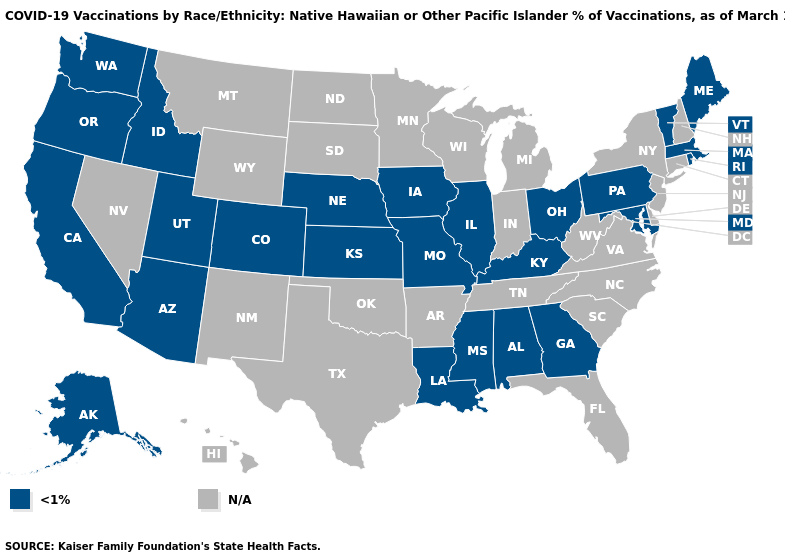Name the states that have a value in the range N/A?
Be succinct. Arkansas, Connecticut, Delaware, Florida, Hawaii, Indiana, Michigan, Minnesota, Montana, Nevada, New Hampshire, New Jersey, New Mexico, New York, North Carolina, North Dakota, Oklahoma, South Carolina, South Dakota, Tennessee, Texas, Virginia, West Virginia, Wisconsin, Wyoming. Name the states that have a value in the range N/A?
Concise answer only. Arkansas, Connecticut, Delaware, Florida, Hawaii, Indiana, Michigan, Minnesota, Montana, Nevada, New Hampshire, New Jersey, New Mexico, New York, North Carolina, North Dakota, Oklahoma, South Carolina, South Dakota, Tennessee, Texas, Virginia, West Virginia, Wisconsin, Wyoming. What is the value of Rhode Island?
Quick response, please. <1%. Does the map have missing data?
Keep it brief. Yes. What is the value of Michigan?
Concise answer only. N/A. Name the states that have a value in the range N/A?
Quick response, please. Arkansas, Connecticut, Delaware, Florida, Hawaii, Indiana, Michigan, Minnesota, Montana, Nevada, New Hampshire, New Jersey, New Mexico, New York, North Carolina, North Dakota, Oklahoma, South Carolina, South Dakota, Tennessee, Texas, Virginia, West Virginia, Wisconsin, Wyoming. Name the states that have a value in the range N/A?
Concise answer only. Arkansas, Connecticut, Delaware, Florida, Hawaii, Indiana, Michigan, Minnesota, Montana, Nevada, New Hampshire, New Jersey, New Mexico, New York, North Carolina, North Dakota, Oklahoma, South Carolina, South Dakota, Tennessee, Texas, Virginia, West Virginia, Wisconsin, Wyoming. What is the lowest value in the Northeast?
Write a very short answer. <1%. How many symbols are there in the legend?
Concise answer only. 2. What is the value of Nebraska?
Write a very short answer. <1%. What is the highest value in states that border New Hampshire?
Keep it brief. <1%. What is the value of Maine?
Answer briefly. <1%. Which states have the highest value in the USA?
Quick response, please. Alabama, Alaska, Arizona, California, Colorado, Georgia, Idaho, Illinois, Iowa, Kansas, Kentucky, Louisiana, Maine, Maryland, Massachusetts, Mississippi, Missouri, Nebraska, Ohio, Oregon, Pennsylvania, Rhode Island, Utah, Vermont, Washington. 